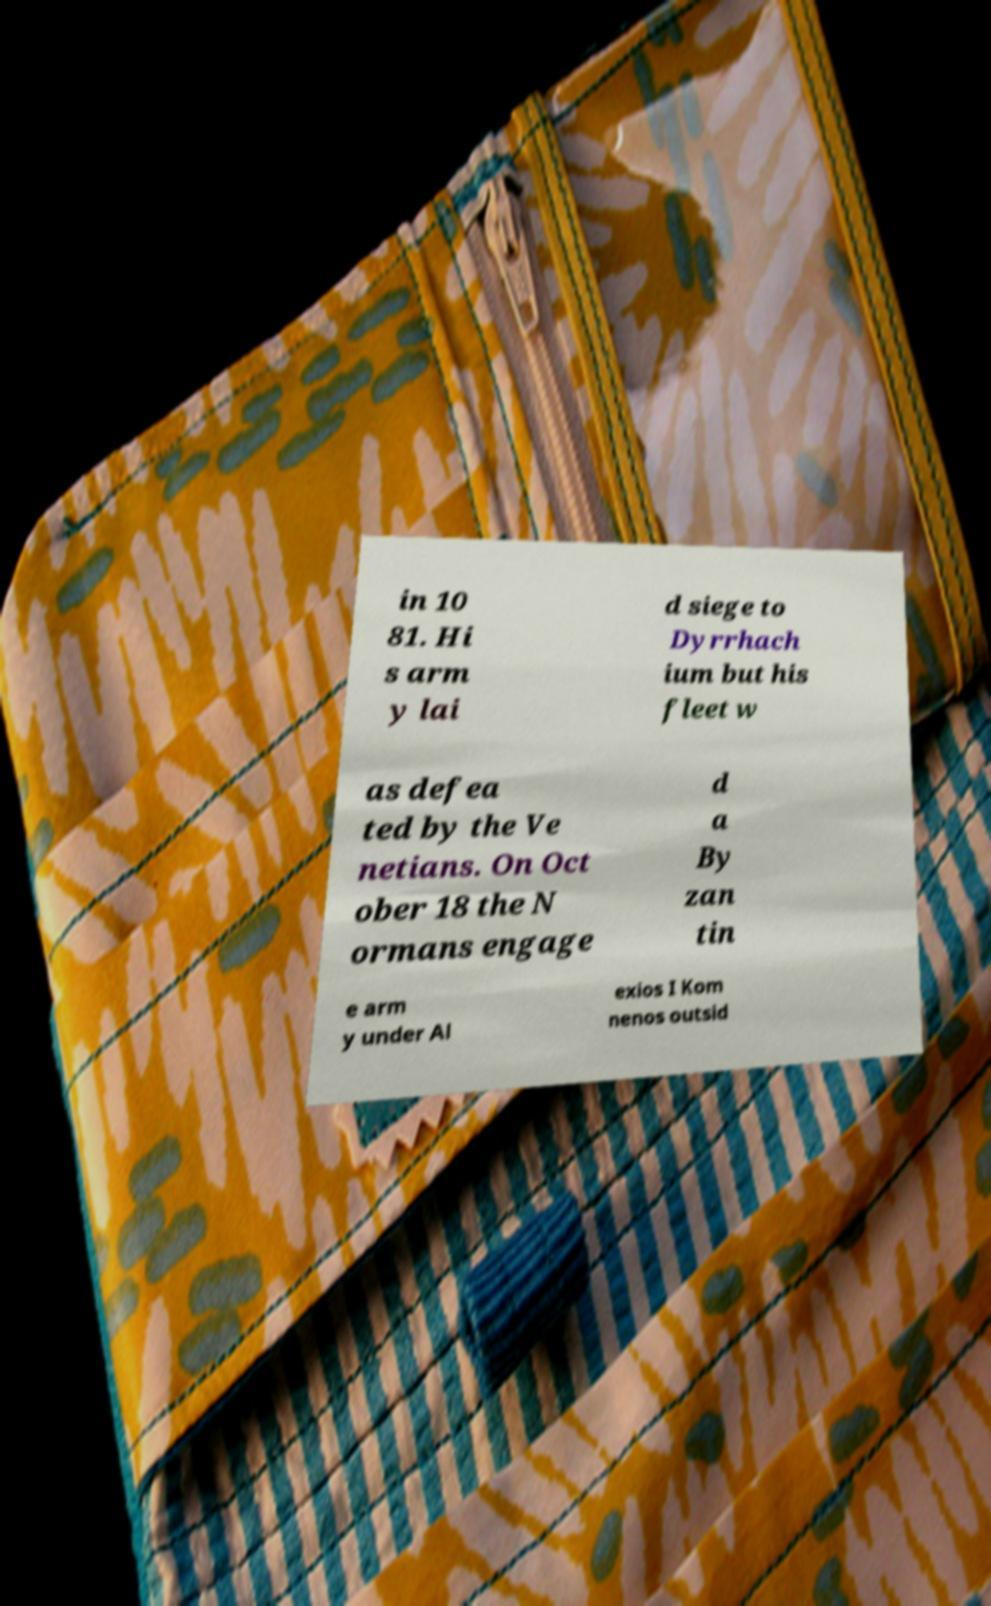Please read and relay the text visible in this image. What does it say? in 10 81. Hi s arm y lai d siege to Dyrrhach ium but his fleet w as defea ted by the Ve netians. On Oct ober 18 the N ormans engage d a By zan tin e arm y under Al exios I Kom nenos outsid 